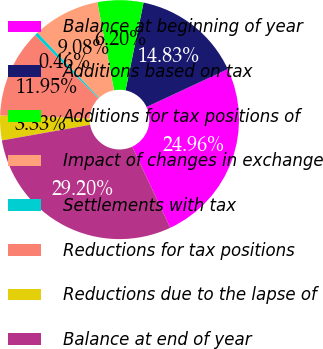Convert chart to OTSL. <chart><loc_0><loc_0><loc_500><loc_500><pie_chart><fcel>Balance at beginning of year<fcel>Additions based on tax<fcel>Additions for tax positions of<fcel>Impact of changes in exchange<fcel>Settlements with tax<fcel>Reductions for tax positions<fcel>Reductions due to the lapse of<fcel>Balance at end of year<nl><fcel>24.96%<fcel>14.83%<fcel>6.2%<fcel>9.08%<fcel>0.46%<fcel>11.95%<fcel>3.33%<fcel>29.2%<nl></chart> 